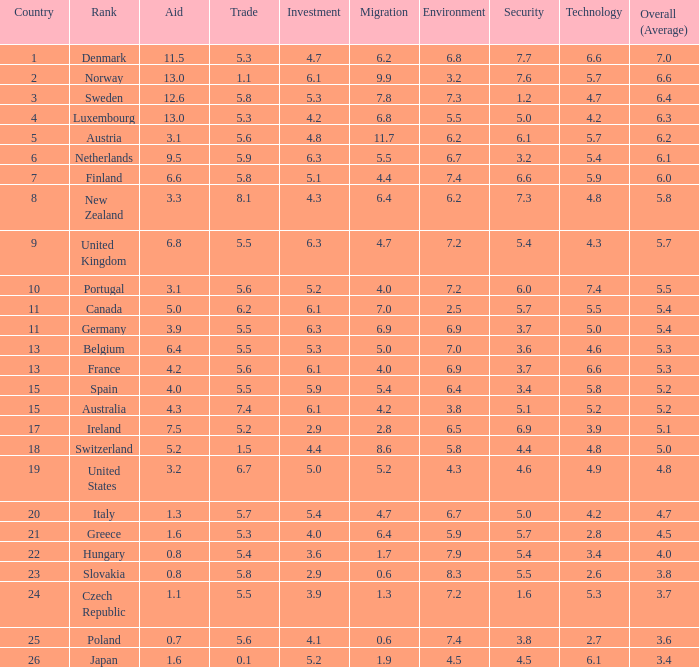What is the environmental assessment of the country that has an overall mean rating of 4.7? 6.7. 